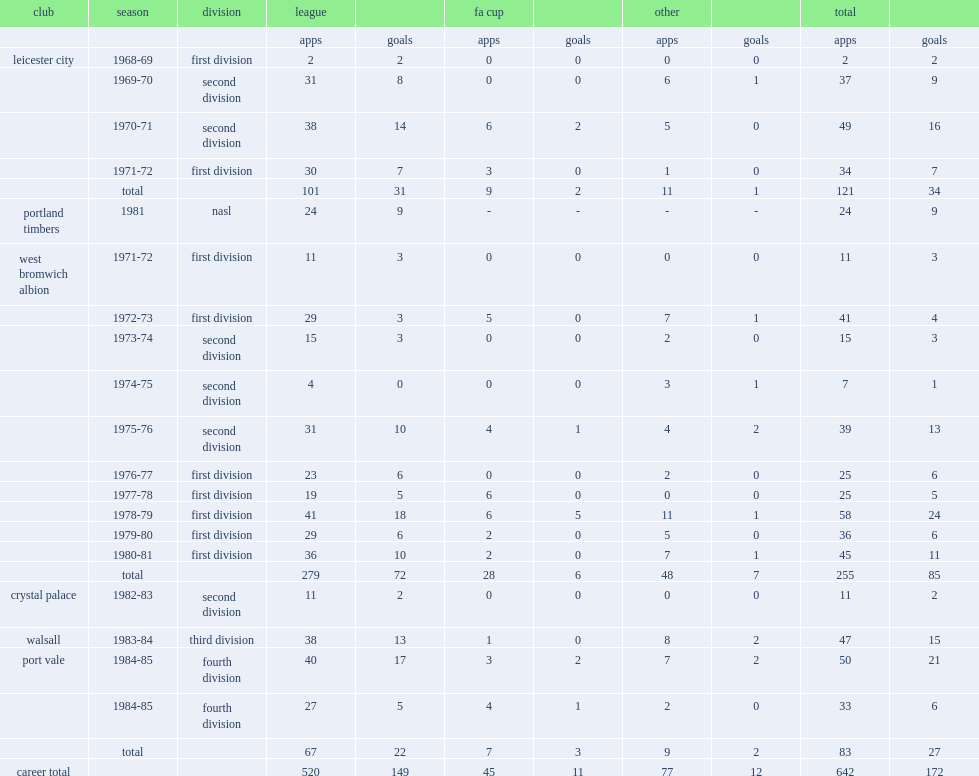How many appearances did the footballer alistair brown (born 1951) make in leicester city? 121.0. 